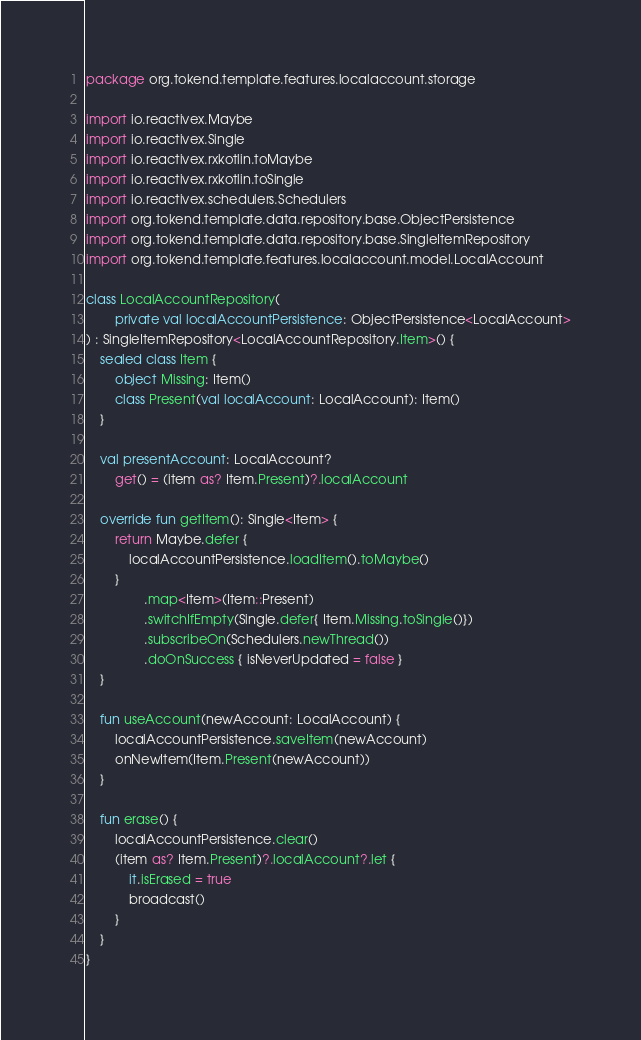Convert code to text. <code><loc_0><loc_0><loc_500><loc_500><_Kotlin_>package org.tokend.template.features.localaccount.storage

import io.reactivex.Maybe
import io.reactivex.Single
import io.reactivex.rxkotlin.toMaybe
import io.reactivex.rxkotlin.toSingle
import io.reactivex.schedulers.Schedulers
import org.tokend.template.data.repository.base.ObjectPersistence
import org.tokend.template.data.repository.base.SingleItemRepository
import org.tokend.template.features.localaccount.model.LocalAccount

class LocalAccountRepository(
        private val localAccountPersistence: ObjectPersistence<LocalAccount>
) : SingleItemRepository<LocalAccountRepository.Item>() {
    sealed class Item {
        object Missing: Item()
        class Present(val localAccount: LocalAccount): Item()
    }

    val presentAccount: LocalAccount?
        get() = (item as? Item.Present)?.localAccount

    override fun getItem(): Single<Item> {
        return Maybe.defer {
            localAccountPersistence.loadItem().toMaybe()
        }
                .map<Item>(Item::Present)
                .switchIfEmpty(Single.defer{ Item.Missing.toSingle()})
                .subscribeOn(Schedulers.newThread())
                .doOnSuccess { isNeverUpdated = false }
    }

    fun useAccount(newAccount: LocalAccount) {
        localAccountPersistence.saveItem(newAccount)
        onNewItem(Item.Present(newAccount))
    }

    fun erase() {
        localAccountPersistence.clear()
        (item as? Item.Present)?.localAccount?.let {
            it.isErased = true
            broadcast()
        }
    }
}</code> 